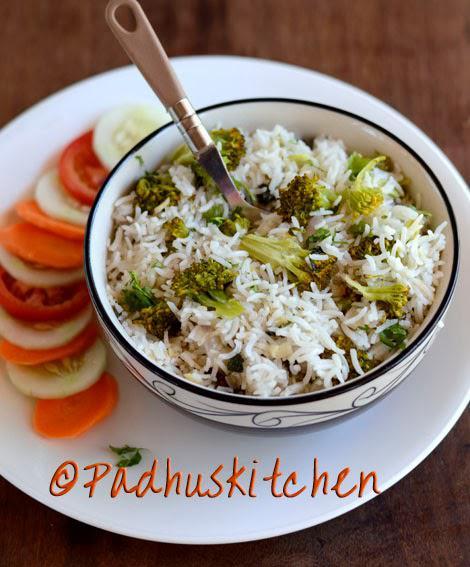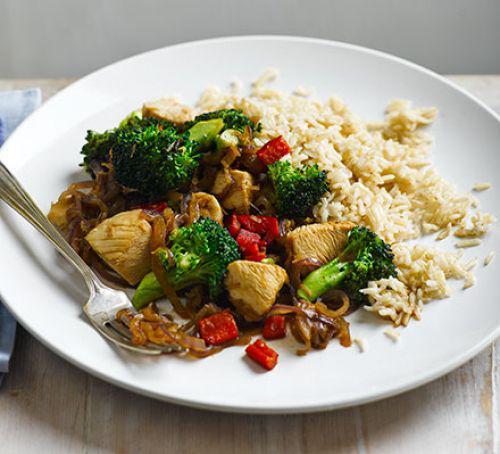The first image is the image on the left, the second image is the image on the right. Examine the images to the left and right. Is the description "There is at least one metal utensil in the image on the right." accurate? Answer yes or no. Yes. 